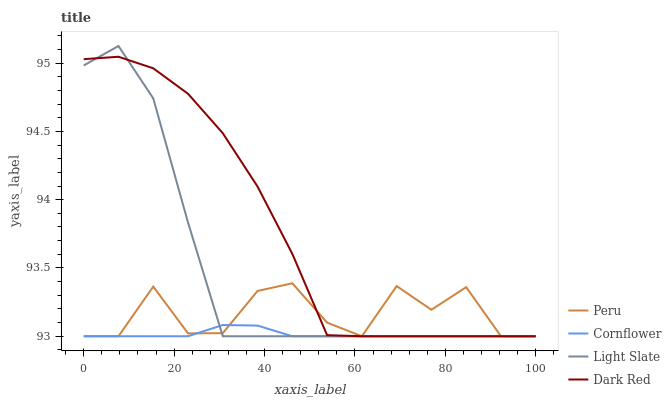Does Peru have the minimum area under the curve?
Answer yes or no. No. Does Peru have the maximum area under the curve?
Answer yes or no. No. Is Peru the smoothest?
Answer yes or no. No. Is Cornflower the roughest?
Answer yes or no. No. Does Peru have the highest value?
Answer yes or no. No. 